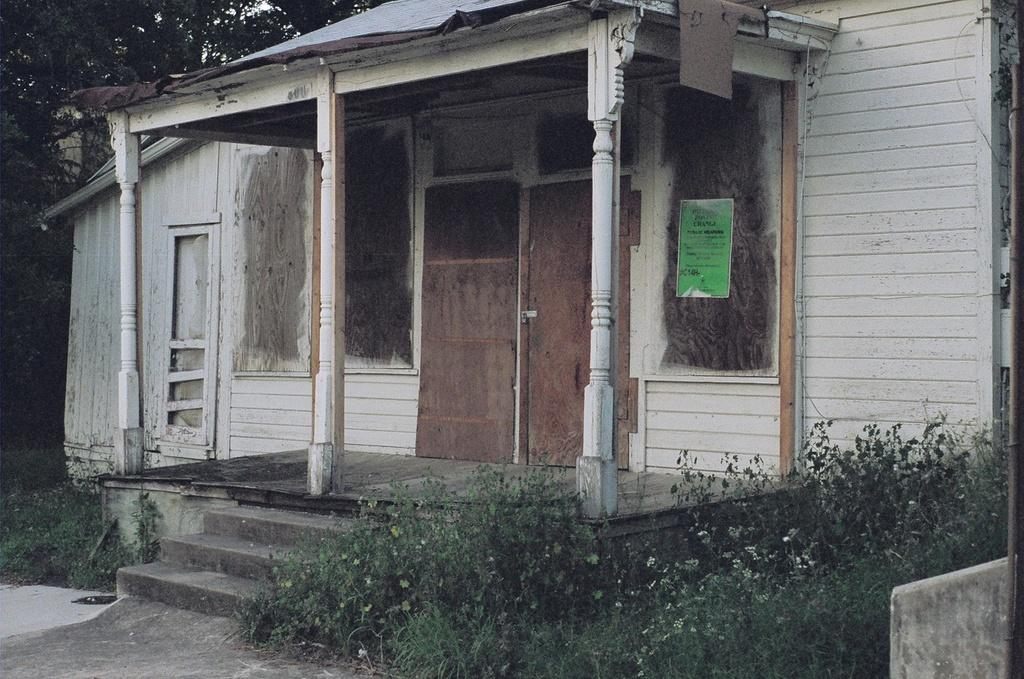What type of structure is depicted in the image? The image is of a house. Where is the main entrance to the house located? There is a door in the center of the house. What can be seen in the foreground of the image? There are plants and a staircase in the foreground, as well as a table. What type of vegetation is visible at the top of the image? Trees are visible at the top of the image. How many brothers are standing next to the picture in the image? There is no picture or brothers present in the image. 